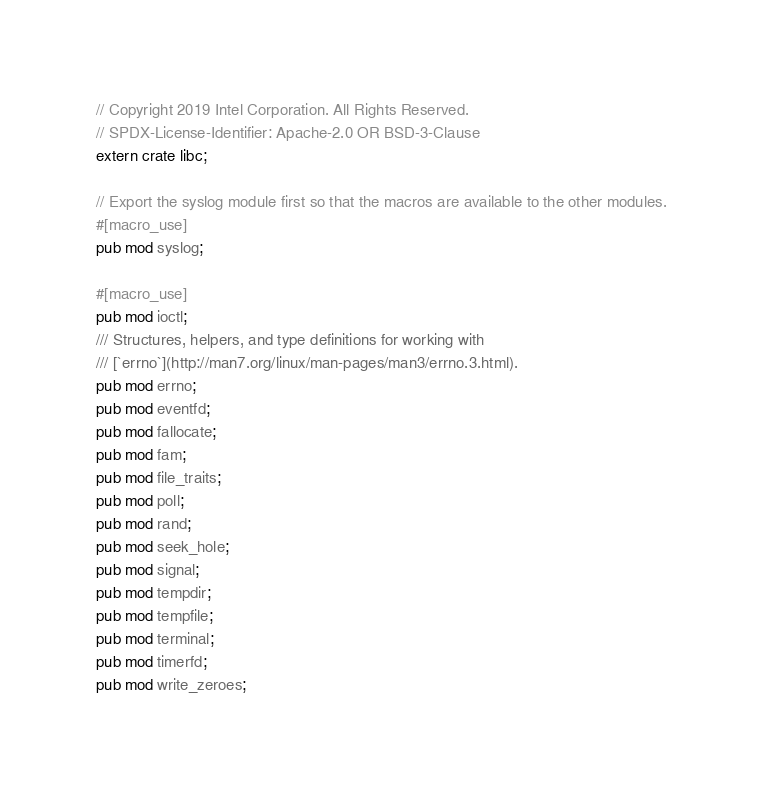<code> <loc_0><loc_0><loc_500><loc_500><_Rust_>// Copyright 2019 Intel Corporation. All Rights Reserved.
// SPDX-License-Identifier: Apache-2.0 OR BSD-3-Clause
extern crate libc;

// Export the syslog module first so that the macros are available to the other modules.
#[macro_use]
pub mod syslog;

#[macro_use]
pub mod ioctl;
/// Structures, helpers, and type definitions for working with
/// [`errno`](http://man7.org/linux/man-pages/man3/errno.3.html).
pub mod errno;
pub mod eventfd;
pub mod fallocate;
pub mod fam;
pub mod file_traits;
pub mod poll;
pub mod rand;
pub mod seek_hole;
pub mod signal;
pub mod tempdir;
pub mod tempfile;
pub mod terminal;
pub mod timerfd;
pub mod write_zeroes;
</code> 